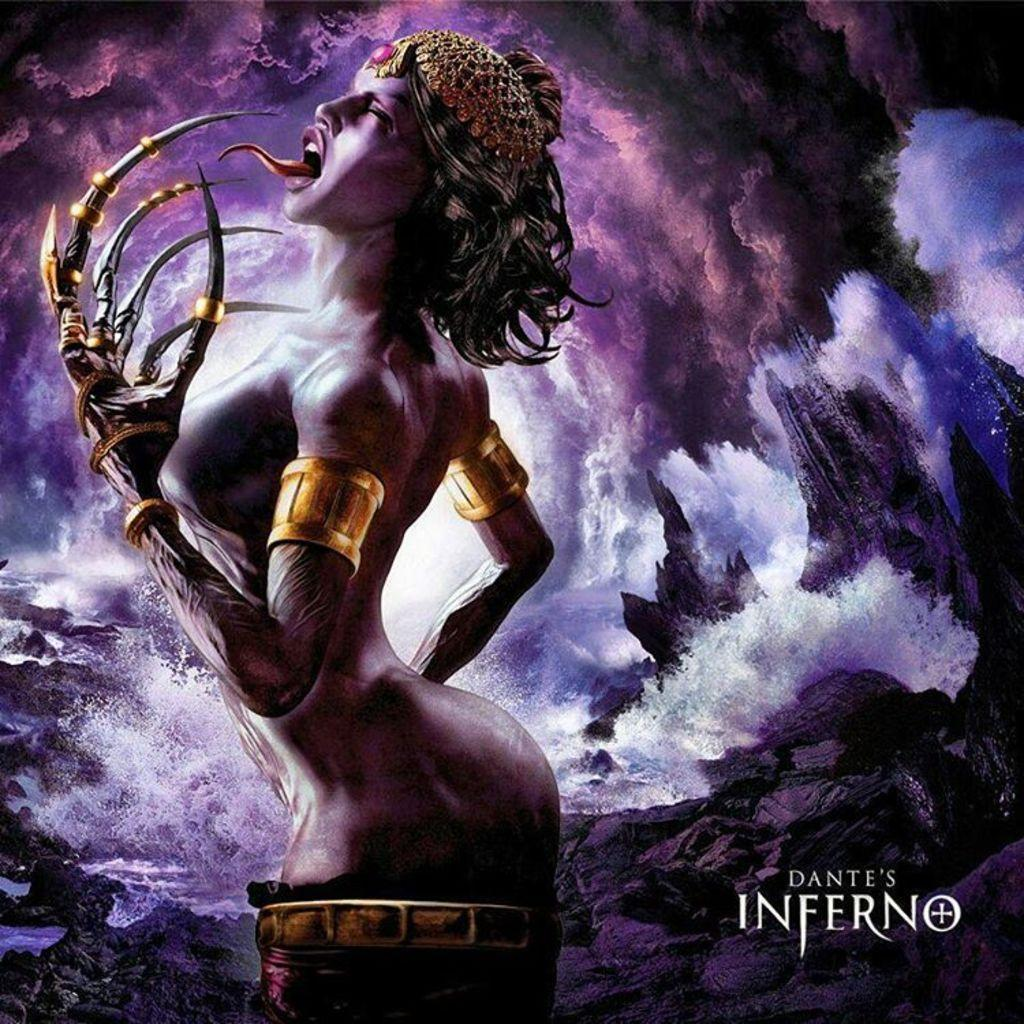Who is the main subject in the image? There is a lady in the image. What is unique about the lady's hands? The lady has demon hands. What type of background is depicted in the image? There is an abstract representation of clouds and an ocean in the image. What type of plane can be seen flying in the image? There is no plane present in the image. Who is the actor playing the role of the lady in the image? There is no actor or role-playing in the image; it is a still image of a lady. 